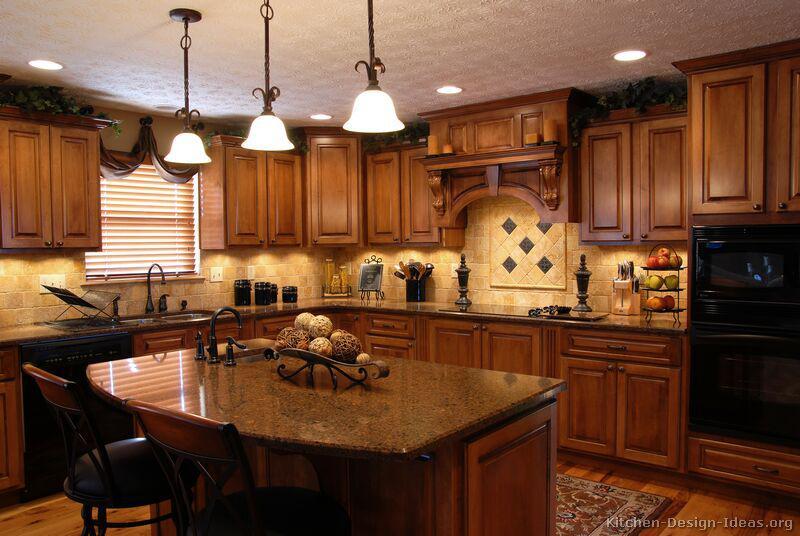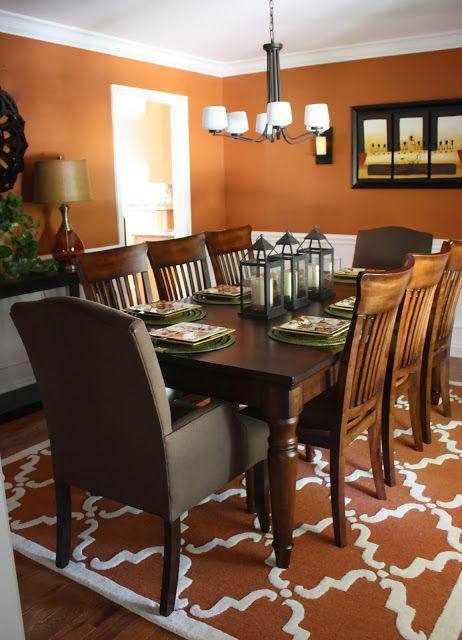The first image is the image on the left, the second image is the image on the right. Given the left and right images, does the statement "In at least one image there are three hanging light over a kitchen island." hold true? Answer yes or no. Yes. 